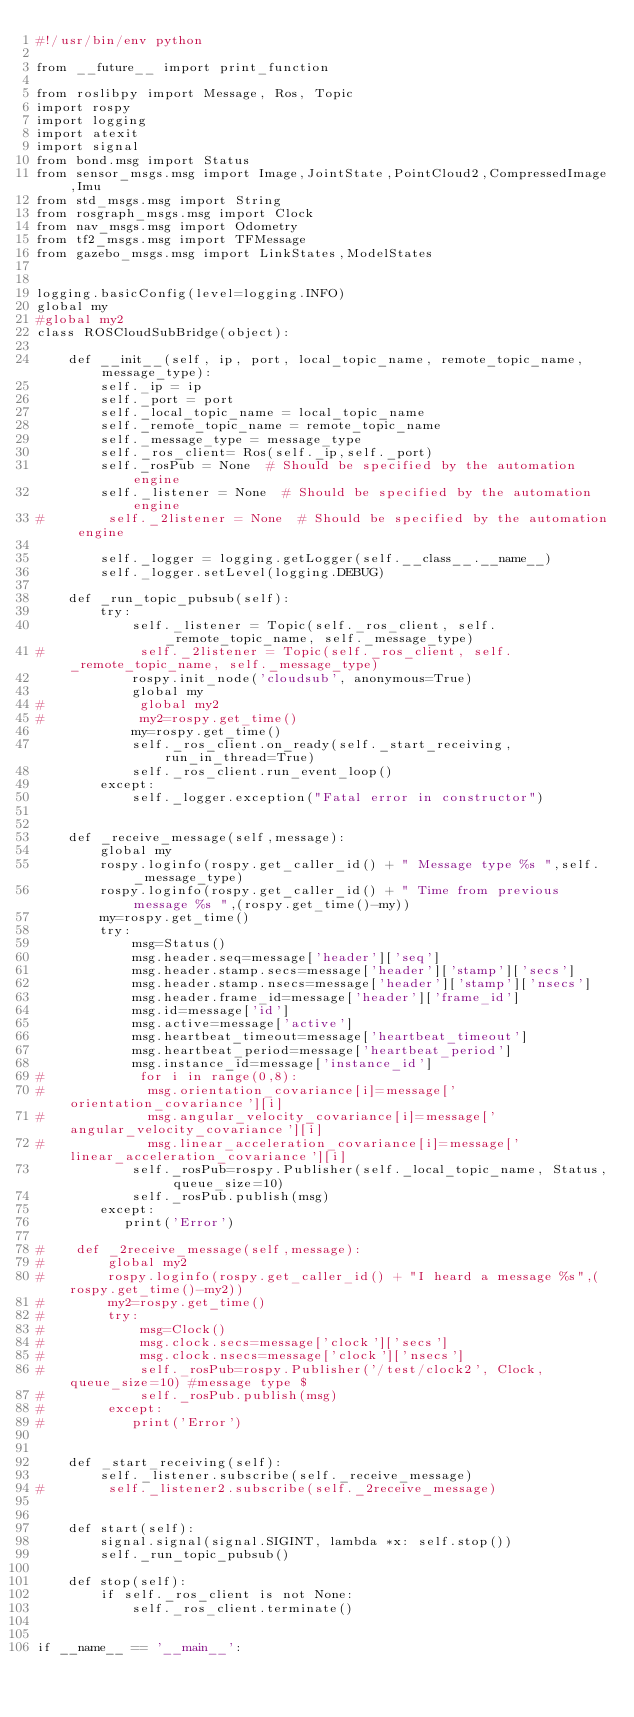<code> <loc_0><loc_0><loc_500><loc_500><_Python_>#!/usr/bin/env python

from __future__ import print_function

from roslibpy import Message, Ros, Topic
import rospy
import logging
import atexit
import signal
from bond.msg import Status
from sensor_msgs.msg import Image,JointState,PointCloud2,CompressedImage,Imu
from std_msgs.msg import String
from rosgraph_msgs.msg import Clock
from nav_msgs.msg import Odometry
from tf2_msgs.msg import TFMessage
from gazebo_msgs.msg import LinkStates,ModelStates


logging.basicConfig(level=logging.INFO)
global my
#global my2
class ROSCloudSubBridge(object):

    def __init__(self, ip, port, local_topic_name, remote_topic_name, message_type):
        self._ip = ip
        self._port = port
        self._local_topic_name = local_topic_name     
        self._remote_topic_name = remote_topic_name
        self._message_type = message_type
        self._ros_client= Ros(self._ip,self._port) 
        self._rosPub = None  # Should be specified by the automation engine
        self._listener = None  # Should be specified by the automation engine
#        self._2listener = None  # Should be specified by the automation engine

        self._logger = logging.getLogger(self.__class__.__name__)
        self._logger.setLevel(logging.DEBUG)

    def _run_topic_pubsub(self):
    	try:
            self._listener = Topic(self._ros_client, self._remote_topic_name, self._message_type)
#            self._2listener = Topic(self._ros_client, self._remote_topic_name, self._message_type)
            rospy.init_node('cloudsub', anonymous=True)
            global my
#            global my2
#            my2=rospy.get_time()    
            my=rospy.get_time()
            self._ros_client.on_ready(self._start_receiving, run_in_thread=True)
            self._ros_client.run_event_loop() 
        except:        
            self._logger.exception("Fatal error in constructor")
    

    def _receive_message(self,message):
        global my
        rospy.loginfo(rospy.get_caller_id() + " Message type %s ",self._message_type)
        rospy.loginfo(rospy.get_caller_id() + " Time from previous message %s ",(rospy.get_time()-my))
        my=rospy.get_time()
        try:
            msg=Status()
            msg.header.seq=message['header']['seq']
            msg.header.stamp.secs=message['header']['stamp']['secs']
            msg.header.stamp.nsecs=message['header']['stamp']['nsecs']
            msg.header.frame_id=message['header']['frame_id']
            msg.id=message['id']
            msg.active=message['active']
            msg.heartbeat_timeout=message['heartbeat_timeout']
            msg.heartbeat_period=message['heartbeat_period']    
            msg.instance_id=message['instance_id']
#            for i in range(0,8):
#             msg.orientation_covariance[i]=message['orientation_covariance'][i]
#             msg.angular_velocity_covariance[i]=message['angular_velocity_covariance'][i]
#             msg.linear_acceleration_covariance[i]=message['linear_acceleration_covariance'][i]
            self._rosPub=rospy.Publisher(self._local_topic_name, Status, queue_size=10)
            self._rosPub.publish(msg)
        except:
           print('Error')        

#    def _2receive_message(self,message):
#        global my2
#        rospy.loginfo(rospy.get_caller_id() + "I heard a message %s",(rospy.get_time()-my2))
#        my2=rospy.get_time()
#        try:
#            msg=Clock()
#            msg.clock.secs=message['clock']['secs']
#            msg.clock.nsecs=message['clock']['nsecs']
#            self._rosPub=rospy.Publisher('/test/clock2', Clock, queue_size=10) #message type $
#            self._rosPub.publish(msg)
#        except:
#           print('Error')        


    def _start_receiving(self): 
        self._listener.subscribe(self._receive_message)
#        self._listener2.subscribe(self._2receive_message)


    def start(self):
        signal.signal(signal.SIGINT, lambda *x: self.stop())
        self._run_topic_pubsub()

    def stop(self):
        if self._ros_client is not None:
            self._ros_client.terminate()


if __name__ == '__main__':</code> 